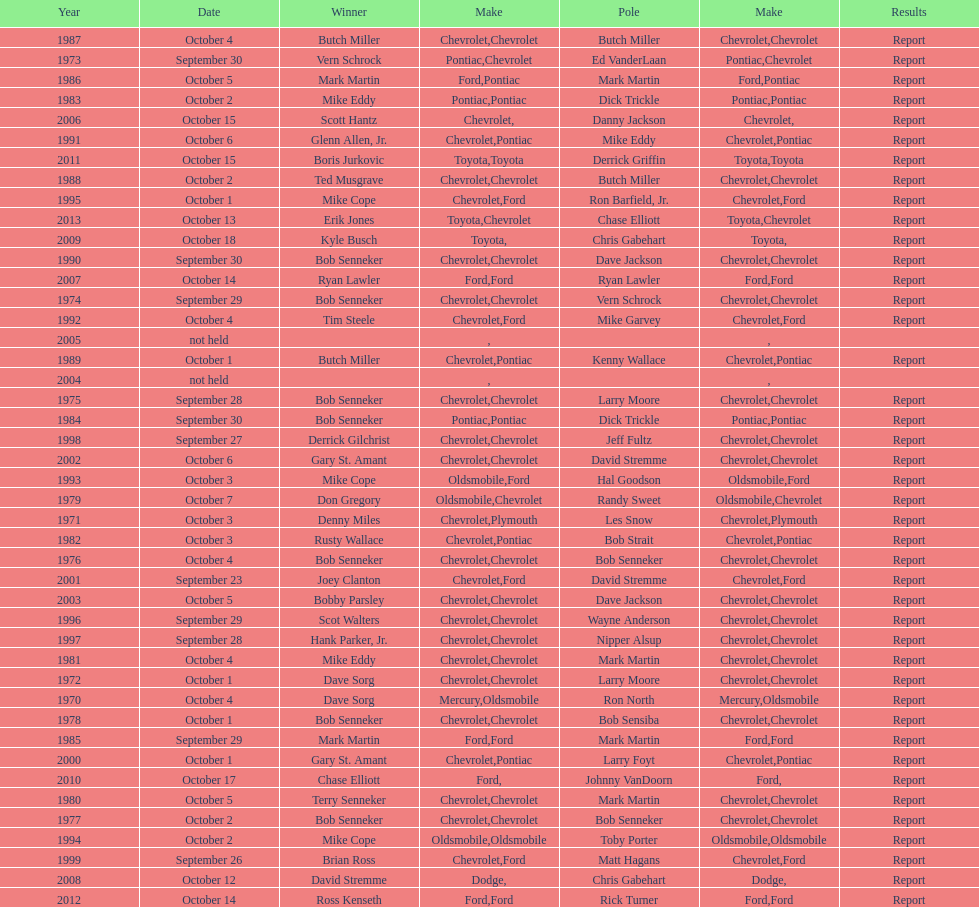Which month held the most winchester 400 races? October. 